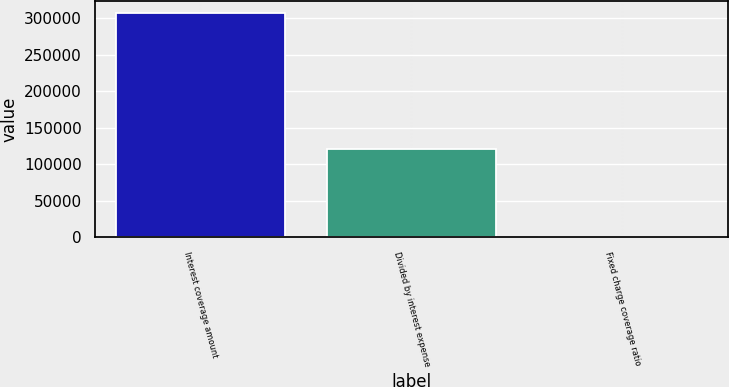Convert chart. <chart><loc_0><loc_0><loc_500><loc_500><bar_chart><fcel>Interest coverage amount<fcel>Divided by interest expense<fcel>Fixed charge coverage ratio<nl><fcel>307304<fcel>120006<fcel>2.6<nl></chart> 